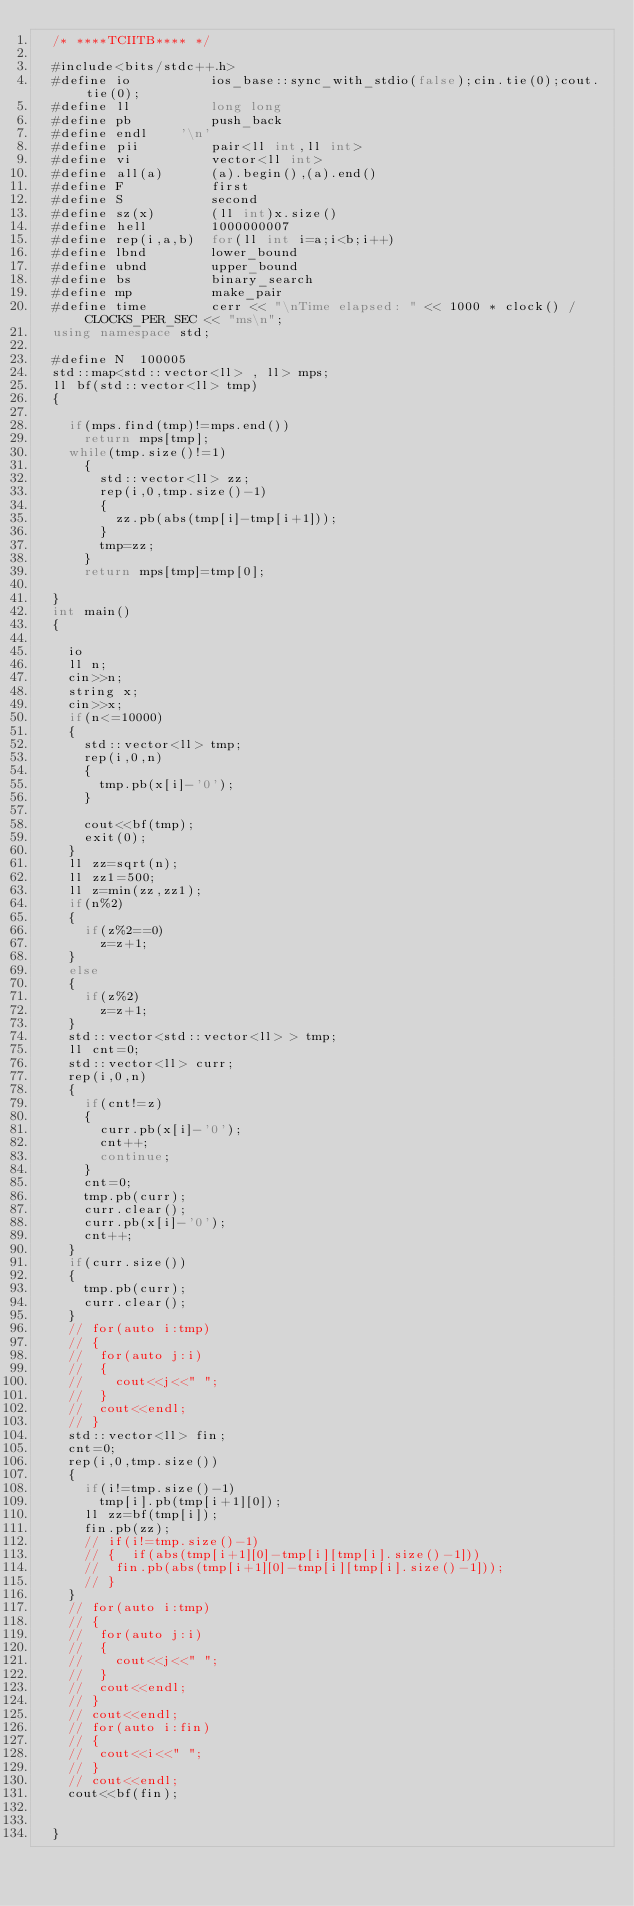Convert code to text. <code><loc_0><loc_0><loc_500><loc_500><_C++_>	/* ****TCIITB**** */

	#include<bits/stdc++.h>
	#define io          ios_base::sync_with_stdio(false);cin.tie(0);cout.tie(0); 
	#define ll          long long
	#define pb          push_back
	#define	endl		'\n'
	#define pii         pair<ll int,ll int>
	#define vi          vector<ll int>
	#define all(a)      (a).begin(),(a).end()
	#define F           first
	#define S           second
	#define sz(x)       (ll int)x.size()
	#define hell        1000000007
	#define rep(i,a,b)	for(ll int i=a;i<b;i++)
	#define lbnd        lower_bound
	#define ubnd        upper_bound
	#define bs          binary_search
	#define mp          make_pair
	#define time        cerr << "\nTime elapsed: " << 1000 * clock() / CLOCKS_PER_SEC << "ms\n";
	using namespace std;

	#define N  100005
	std::map<std::vector<ll> , ll> mps;
	ll bf(std::vector<ll> tmp)
	{

		if(mps.find(tmp)!=mps.end())
			return mps[tmp];
		while(tmp.size()!=1)
			{
				std::vector<ll> zz;
				rep(i,0,tmp.size()-1)
				{
					zz.pb(abs(tmp[i]-tmp[i+1]));
				}
				tmp=zz;
			}
			return mps[tmp]=tmp[0];

	}
	int main()
	{
		
		io
		ll n;
		cin>>n;
		string x;
		cin>>x;	
		if(n<=10000)
		{
			std::vector<ll> tmp;
			rep(i,0,n)
			{
				tmp.pb(x[i]-'0');
			}
			
			cout<<bf(tmp);
			exit(0);
		}
		ll zz=sqrt(n);
		ll zz1=500;
		ll z=min(zz,zz1);
		if(n%2)
		{
			if(z%2==0)
				z=z+1;
		}
		else
		{
			if(z%2)
				z=z+1;
		}
		std::vector<std::vector<ll> > tmp;
		ll cnt=0;
		std::vector<ll> curr;
		rep(i,0,n)
		{
			if(cnt!=z)
			{
				curr.pb(x[i]-'0');
				cnt++;
				continue;
			}
			cnt=0;
			tmp.pb(curr);
			curr.clear();
			curr.pb(x[i]-'0');
			cnt++;
		}
		if(curr.size())
		{
			tmp.pb(curr);
			curr.clear();
		}
		// for(auto i:tmp)
		// {
		// 	for(auto j:i)
		// 	{
		// 		cout<<j<<" ";
		// 	}
		// 	cout<<endl;
		// }
		std::vector<ll> fin;
		cnt=0;
		rep(i,0,tmp.size())
		{
			if(i!=tmp.size()-1)
				tmp[i].pb(tmp[i+1][0]);
			ll zz=bf(tmp[i]);
			fin.pb(zz);
			// if(i!=tmp.size()-1)
			// {	if(abs(tmp[i+1][0]-tmp[i][tmp[i].size()-1]))
			// 	fin.pb(abs(tmp[i+1][0]-tmp[i][tmp[i].size()-1]));
			// }		
		}	
		// for(auto i:tmp)
		// {
		// 	for(auto j:i)
		// 	{
		// 		cout<<j<<" ";
		// 	}
		// 	cout<<endl;
		// }
		// cout<<endl;
		// for(auto i:fin)
		// {
		// 	cout<<i<<" ";
		// }
		// cout<<endl;
		cout<<bf(fin);

		
	}</code> 